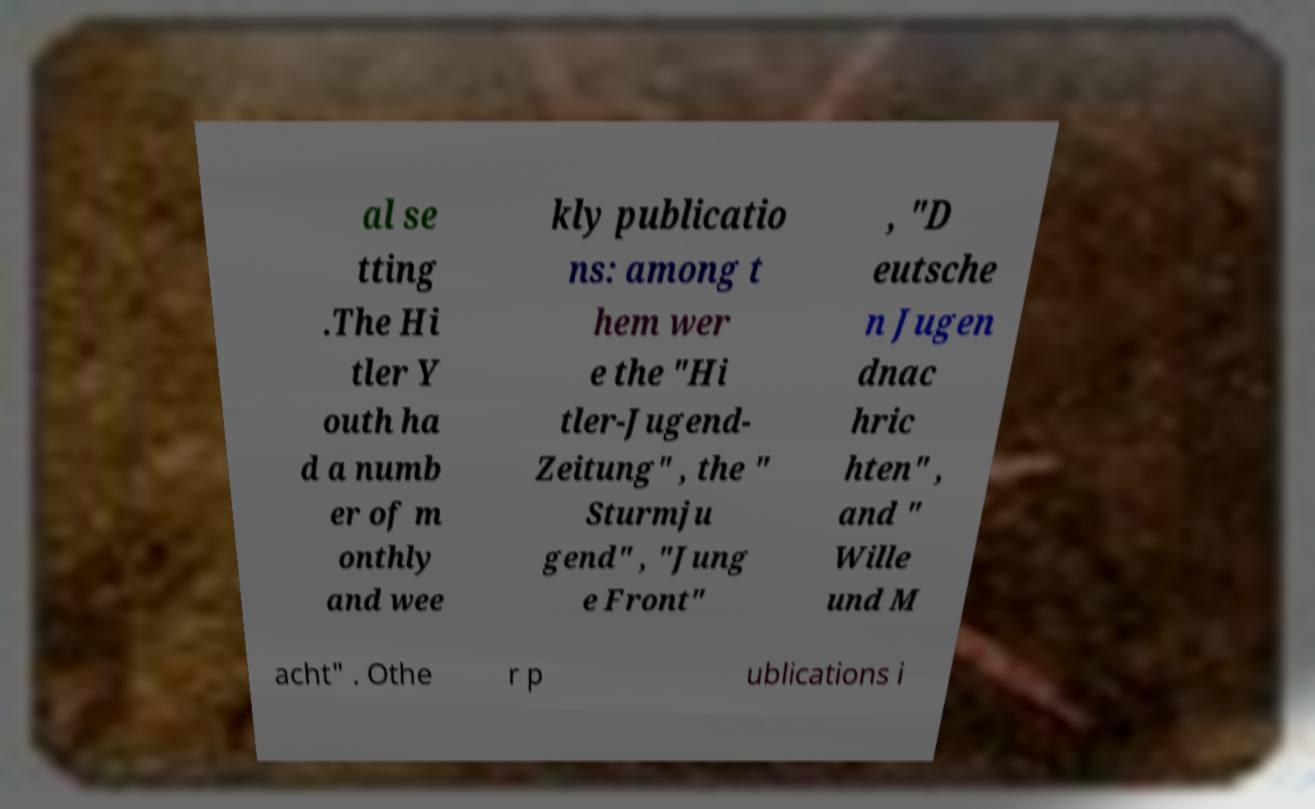Could you assist in decoding the text presented in this image and type it out clearly? al se tting .The Hi tler Y outh ha d a numb er of m onthly and wee kly publicatio ns: among t hem wer e the "Hi tler-Jugend- Zeitung" , the " Sturmju gend" , "Jung e Front" , "D eutsche n Jugen dnac hric hten" , and " Wille und M acht" . Othe r p ublications i 